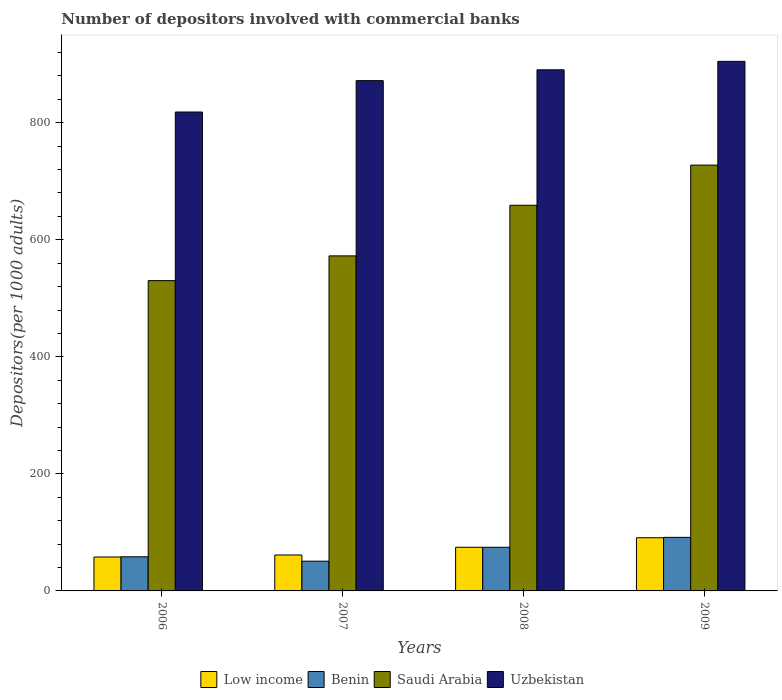How many different coloured bars are there?
Provide a succinct answer. 4. How many bars are there on the 3rd tick from the left?
Keep it short and to the point. 4. How many bars are there on the 2nd tick from the right?
Your answer should be compact. 4. What is the number of depositors involved with commercial banks in Benin in 2006?
Give a very brief answer. 58.31. Across all years, what is the maximum number of depositors involved with commercial banks in Saudi Arabia?
Provide a short and direct response. 727.65. Across all years, what is the minimum number of depositors involved with commercial banks in Low income?
Keep it short and to the point. 57.99. In which year was the number of depositors involved with commercial banks in Uzbekistan maximum?
Offer a very short reply. 2009. In which year was the number of depositors involved with commercial banks in Saudi Arabia minimum?
Your answer should be very brief. 2006. What is the total number of depositors involved with commercial banks in Low income in the graph?
Give a very brief answer. 284.91. What is the difference between the number of depositors involved with commercial banks in Uzbekistan in 2006 and that in 2007?
Ensure brevity in your answer.  -53.61. What is the difference between the number of depositors involved with commercial banks in Saudi Arabia in 2008 and the number of depositors involved with commercial banks in Uzbekistan in 2006?
Provide a succinct answer. -159.38. What is the average number of depositors involved with commercial banks in Saudi Arabia per year?
Your answer should be compact. 622.35. In the year 2008, what is the difference between the number of depositors involved with commercial banks in Saudi Arabia and number of depositors involved with commercial banks in Benin?
Provide a short and direct response. 584.4. What is the ratio of the number of depositors involved with commercial banks in Benin in 2007 to that in 2009?
Offer a very short reply. 0.56. What is the difference between the highest and the second highest number of depositors involved with commercial banks in Benin?
Offer a very short reply. 16.94. What is the difference between the highest and the lowest number of depositors involved with commercial banks in Saudi Arabia?
Give a very brief answer. 197.41. In how many years, is the number of depositors involved with commercial banks in Uzbekistan greater than the average number of depositors involved with commercial banks in Uzbekistan taken over all years?
Give a very brief answer. 3. Is it the case that in every year, the sum of the number of depositors involved with commercial banks in Uzbekistan and number of depositors involved with commercial banks in Saudi Arabia is greater than the sum of number of depositors involved with commercial banks in Low income and number of depositors involved with commercial banks in Benin?
Make the answer very short. Yes. What does the 4th bar from the left in 2006 represents?
Your answer should be compact. Uzbekistan. What does the 2nd bar from the right in 2006 represents?
Provide a succinct answer. Saudi Arabia. How many bars are there?
Offer a terse response. 16. Are all the bars in the graph horizontal?
Keep it short and to the point. No. How many years are there in the graph?
Your answer should be compact. 4. What is the difference between two consecutive major ticks on the Y-axis?
Keep it short and to the point. 200. Are the values on the major ticks of Y-axis written in scientific E-notation?
Keep it short and to the point. No. Does the graph contain grids?
Make the answer very short. No. How are the legend labels stacked?
Offer a terse response. Horizontal. What is the title of the graph?
Your answer should be very brief. Number of depositors involved with commercial banks. Does "Zimbabwe" appear as one of the legend labels in the graph?
Give a very brief answer. No. What is the label or title of the Y-axis?
Offer a very short reply. Depositors(per 1000 adults). What is the Depositors(per 1000 adults) in Low income in 2006?
Keep it short and to the point. 57.99. What is the Depositors(per 1000 adults) in Benin in 2006?
Provide a short and direct response. 58.31. What is the Depositors(per 1000 adults) of Saudi Arabia in 2006?
Your answer should be very brief. 530.23. What is the Depositors(per 1000 adults) of Uzbekistan in 2006?
Keep it short and to the point. 818.38. What is the Depositors(per 1000 adults) of Low income in 2007?
Your response must be concise. 61.41. What is the Depositors(per 1000 adults) in Benin in 2007?
Your answer should be very brief. 50.82. What is the Depositors(per 1000 adults) of Saudi Arabia in 2007?
Provide a succinct answer. 572.53. What is the Depositors(per 1000 adults) in Uzbekistan in 2007?
Provide a succinct answer. 871.99. What is the Depositors(per 1000 adults) of Low income in 2008?
Offer a terse response. 74.6. What is the Depositors(per 1000 adults) in Benin in 2008?
Give a very brief answer. 74.6. What is the Depositors(per 1000 adults) in Saudi Arabia in 2008?
Offer a terse response. 659. What is the Depositors(per 1000 adults) of Uzbekistan in 2008?
Ensure brevity in your answer.  890.51. What is the Depositors(per 1000 adults) of Low income in 2009?
Give a very brief answer. 90.91. What is the Depositors(per 1000 adults) of Benin in 2009?
Your response must be concise. 91.54. What is the Depositors(per 1000 adults) of Saudi Arabia in 2009?
Keep it short and to the point. 727.65. What is the Depositors(per 1000 adults) of Uzbekistan in 2009?
Your response must be concise. 904.94. Across all years, what is the maximum Depositors(per 1000 adults) of Low income?
Your answer should be very brief. 90.91. Across all years, what is the maximum Depositors(per 1000 adults) in Benin?
Your response must be concise. 91.54. Across all years, what is the maximum Depositors(per 1000 adults) in Saudi Arabia?
Provide a succinct answer. 727.65. Across all years, what is the maximum Depositors(per 1000 adults) in Uzbekistan?
Offer a very short reply. 904.94. Across all years, what is the minimum Depositors(per 1000 adults) of Low income?
Give a very brief answer. 57.99. Across all years, what is the minimum Depositors(per 1000 adults) of Benin?
Your answer should be very brief. 50.82. Across all years, what is the minimum Depositors(per 1000 adults) in Saudi Arabia?
Your response must be concise. 530.23. Across all years, what is the minimum Depositors(per 1000 adults) in Uzbekistan?
Keep it short and to the point. 818.38. What is the total Depositors(per 1000 adults) of Low income in the graph?
Provide a short and direct response. 284.91. What is the total Depositors(per 1000 adults) of Benin in the graph?
Provide a short and direct response. 275.28. What is the total Depositors(per 1000 adults) of Saudi Arabia in the graph?
Give a very brief answer. 2489.41. What is the total Depositors(per 1000 adults) of Uzbekistan in the graph?
Provide a succinct answer. 3485.81. What is the difference between the Depositors(per 1000 adults) of Low income in 2006 and that in 2007?
Your response must be concise. -3.42. What is the difference between the Depositors(per 1000 adults) in Benin in 2006 and that in 2007?
Keep it short and to the point. 7.5. What is the difference between the Depositors(per 1000 adults) in Saudi Arabia in 2006 and that in 2007?
Ensure brevity in your answer.  -42.3. What is the difference between the Depositors(per 1000 adults) of Uzbekistan in 2006 and that in 2007?
Provide a short and direct response. -53.61. What is the difference between the Depositors(per 1000 adults) in Low income in 2006 and that in 2008?
Offer a terse response. -16.61. What is the difference between the Depositors(per 1000 adults) in Benin in 2006 and that in 2008?
Offer a very short reply. -16.29. What is the difference between the Depositors(per 1000 adults) in Saudi Arabia in 2006 and that in 2008?
Give a very brief answer. -128.77. What is the difference between the Depositors(per 1000 adults) in Uzbekistan in 2006 and that in 2008?
Your response must be concise. -72.13. What is the difference between the Depositors(per 1000 adults) of Low income in 2006 and that in 2009?
Keep it short and to the point. -32.92. What is the difference between the Depositors(per 1000 adults) of Benin in 2006 and that in 2009?
Offer a very short reply. -33.23. What is the difference between the Depositors(per 1000 adults) of Saudi Arabia in 2006 and that in 2009?
Make the answer very short. -197.41. What is the difference between the Depositors(per 1000 adults) in Uzbekistan in 2006 and that in 2009?
Your response must be concise. -86.56. What is the difference between the Depositors(per 1000 adults) of Low income in 2007 and that in 2008?
Make the answer very short. -13.19. What is the difference between the Depositors(per 1000 adults) in Benin in 2007 and that in 2008?
Provide a succinct answer. -23.78. What is the difference between the Depositors(per 1000 adults) of Saudi Arabia in 2007 and that in 2008?
Make the answer very short. -86.47. What is the difference between the Depositors(per 1000 adults) of Uzbekistan in 2007 and that in 2008?
Give a very brief answer. -18.52. What is the difference between the Depositors(per 1000 adults) of Low income in 2007 and that in 2009?
Your response must be concise. -29.5. What is the difference between the Depositors(per 1000 adults) of Benin in 2007 and that in 2009?
Give a very brief answer. -40.72. What is the difference between the Depositors(per 1000 adults) in Saudi Arabia in 2007 and that in 2009?
Make the answer very short. -155.11. What is the difference between the Depositors(per 1000 adults) of Uzbekistan in 2007 and that in 2009?
Offer a very short reply. -32.96. What is the difference between the Depositors(per 1000 adults) in Low income in 2008 and that in 2009?
Your response must be concise. -16.31. What is the difference between the Depositors(per 1000 adults) in Benin in 2008 and that in 2009?
Make the answer very short. -16.94. What is the difference between the Depositors(per 1000 adults) of Saudi Arabia in 2008 and that in 2009?
Keep it short and to the point. -68.64. What is the difference between the Depositors(per 1000 adults) in Uzbekistan in 2008 and that in 2009?
Provide a succinct answer. -14.44. What is the difference between the Depositors(per 1000 adults) of Low income in 2006 and the Depositors(per 1000 adults) of Benin in 2007?
Make the answer very short. 7.17. What is the difference between the Depositors(per 1000 adults) of Low income in 2006 and the Depositors(per 1000 adults) of Saudi Arabia in 2007?
Keep it short and to the point. -514.54. What is the difference between the Depositors(per 1000 adults) of Low income in 2006 and the Depositors(per 1000 adults) of Uzbekistan in 2007?
Your answer should be compact. -814. What is the difference between the Depositors(per 1000 adults) in Benin in 2006 and the Depositors(per 1000 adults) in Saudi Arabia in 2007?
Your response must be concise. -514.22. What is the difference between the Depositors(per 1000 adults) of Benin in 2006 and the Depositors(per 1000 adults) of Uzbekistan in 2007?
Offer a terse response. -813.67. What is the difference between the Depositors(per 1000 adults) in Saudi Arabia in 2006 and the Depositors(per 1000 adults) in Uzbekistan in 2007?
Your answer should be very brief. -341.75. What is the difference between the Depositors(per 1000 adults) in Low income in 2006 and the Depositors(per 1000 adults) in Benin in 2008?
Offer a terse response. -16.61. What is the difference between the Depositors(per 1000 adults) in Low income in 2006 and the Depositors(per 1000 adults) in Saudi Arabia in 2008?
Your answer should be very brief. -601.01. What is the difference between the Depositors(per 1000 adults) in Low income in 2006 and the Depositors(per 1000 adults) in Uzbekistan in 2008?
Make the answer very short. -832.51. What is the difference between the Depositors(per 1000 adults) of Benin in 2006 and the Depositors(per 1000 adults) of Saudi Arabia in 2008?
Your response must be concise. -600.69. What is the difference between the Depositors(per 1000 adults) of Benin in 2006 and the Depositors(per 1000 adults) of Uzbekistan in 2008?
Offer a very short reply. -832.19. What is the difference between the Depositors(per 1000 adults) of Saudi Arabia in 2006 and the Depositors(per 1000 adults) of Uzbekistan in 2008?
Provide a short and direct response. -360.27. What is the difference between the Depositors(per 1000 adults) in Low income in 2006 and the Depositors(per 1000 adults) in Benin in 2009?
Offer a terse response. -33.55. What is the difference between the Depositors(per 1000 adults) in Low income in 2006 and the Depositors(per 1000 adults) in Saudi Arabia in 2009?
Give a very brief answer. -669.66. What is the difference between the Depositors(per 1000 adults) of Low income in 2006 and the Depositors(per 1000 adults) of Uzbekistan in 2009?
Offer a terse response. -846.95. What is the difference between the Depositors(per 1000 adults) in Benin in 2006 and the Depositors(per 1000 adults) in Saudi Arabia in 2009?
Your answer should be very brief. -669.33. What is the difference between the Depositors(per 1000 adults) in Benin in 2006 and the Depositors(per 1000 adults) in Uzbekistan in 2009?
Offer a terse response. -846.63. What is the difference between the Depositors(per 1000 adults) in Saudi Arabia in 2006 and the Depositors(per 1000 adults) in Uzbekistan in 2009?
Offer a very short reply. -374.71. What is the difference between the Depositors(per 1000 adults) in Low income in 2007 and the Depositors(per 1000 adults) in Benin in 2008?
Your answer should be very brief. -13.19. What is the difference between the Depositors(per 1000 adults) in Low income in 2007 and the Depositors(per 1000 adults) in Saudi Arabia in 2008?
Your response must be concise. -597.59. What is the difference between the Depositors(per 1000 adults) in Low income in 2007 and the Depositors(per 1000 adults) in Uzbekistan in 2008?
Your answer should be very brief. -829.1. What is the difference between the Depositors(per 1000 adults) of Benin in 2007 and the Depositors(per 1000 adults) of Saudi Arabia in 2008?
Ensure brevity in your answer.  -608.18. What is the difference between the Depositors(per 1000 adults) of Benin in 2007 and the Depositors(per 1000 adults) of Uzbekistan in 2008?
Offer a terse response. -839.69. What is the difference between the Depositors(per 1000 adults) of Saudi Arabia in 2007 and the Depositors(per 1000 adults) of Uzbekistan in 2008?
Your answer should be very brief. -317.97. What is the difference between the Depositors(per 1000 adults) in Low income in 2007 and the Depositors(per 1000 adults) in Benin in 2009?
Offer a terse response. -30.13. What is the difference between the Depositors(per 1000 adults) of Low income in 2007 and the Depositors(per 1000 adults) of Saudi Arabia in 2009?
Ensure brevity in your answer.  -666.24. What is the difference between the Depositors(per 1000 adults) of Low income in 2007 and the Depositors(per 1000 adults) of Uzbekistan in 2009?
Ensure brevity in your answer.  -843.53. What is the difference between the Depositors(per 1000 adults) in Benin in 2007 and the Depositors(per 1000 adults) in Saudi Arabia in 2009?
Offer a terse response. -676.83. What is the difference between the Depositors(per 1000 adults) in Benin in 2007 and the Depositors(per 1000 adults) in Uzbekistan in 2009?
Offer a very short reply. -854.12. What is the difference between the Depositors(per 1000 adults) of Saudi Arabia in 2007 and the Depositors(per 1000 adults) of Uzbekistan in 2009?
Your response must be concise. -332.41. What is the difference between the Depositors(per 1000 adults) of Low income in 2008 and the Depositors(per 1000 adults) of Benin in 2009?
Your response must be concise. -16.94. What is the difference between the Depositors(per 1000 adults) of Low income in 2008 and the Depositors(per 1000 adults) of Saudi Arabia in 2009?
Your answer should be very brief. -653.05. What is the difference between the Depositors(per 1000 adults) of Low income in 2008 and the Depositors(per 1000 adults) of Uzbekistan in 2009?
Provide a succinct answer. -830.34. What is the difference between the Depositors(per 1000 adults) of Benin in 2008 and the Depositors(per 1000 adults) of Saudi Arabia in 2009?
Your answer should be very brief. -653.05. What is the difference between the Depositors(per 1000 adults) of Benin in 2008 and the Depositors(per 1000 adults) of Uzbekistan in 2009?
Your answer should be very brief. -830.34. What is the difference between the Depositors(per 1000 adults) in Saudi Arabia in 2008 and the Depositors(per 1000 adults) in Uzbekistan in 2009?
Offer a very short reply. -245.94. What is the average Depositors(per 1000 adults) of Low income per year?
Your answer should be compact. 71.23. What is the average Depositors(per 1000 adults) in Benin per year?
Your response must be concise. 68.82. What is the average Depositors(per 1000 adults) of Saudi Arabia per year?
Make the answer very short. 622.35. What is the average Depositors(per 1000 adults) of Uzbekistan per year?
Make the answer very short. 871.45. In the year 2006, what is the difference between the Depositors(per 1000 adults) in Low income and Depositors(per 1000 adults) in Benin?
Offer a very short reply. -0.32. In the year 2006, what is the difference between the Depositors(per 1000 adults) of Low income and Depositors(per 1000 adults) of Saudi Arabia?
Give a very brief answer. -472.24. In the year 2006, what is the difference between the Depositors(per 1000 adults) in Low income and Depositors(per 1000 adults) in Uzbekistan?
Offer a very short reply. -760.39. In the year 2006, what is the difference between the Depositors(per 1000 adults) in Benin and Depositors(per 1000 adults) in Saudi Arabia?
Ensure brevity in your answer.  -471.92. In the year 2006, what is the difference between the Depositors(per 1000 adults) of Benin and Depositors(per 1000 adults) of Uzbekistan?
Your response must be concise. -760.06. In the year 2006, what is the difference between the Depositors(per 1000 adults) of Saudi Arabia and Depositors(per 1000 adults) of Uzbekistan?
Your answer should be very brief. -288.15. In the year 2007, what is the difference between the Depositors(per 1000 adults) of Low income and Depositors(per 1000 adults) of Benin?
Your answer should be very brief. 10.59. In the year 2007, what is the difference between the Depositors(per 1000 adults) of Low income and Depositors(per 1000 adults) of Saudi Arabia?
Offer a very short reply. -511.12. In the year 2007, what is the difference between the Depositors(per 1000 adults) in Low income and Depositors(per 1000 adults) in Uzbekistan?
Provide a succinct answer. -810.58. In the year 2007, what is the difference between the Depositors(per 1000 adults) of Benin and Depositors(per 1000 adults) of Saudi Arabia?
Make the answer very short. -521.71. In the year 2007, what is the difference between the Depositors(per 1000 adults) of Benin and Depositors(per 1000 adults) of Uzbekistan?
Your answer should be compact. -821.17. In the year 2007, what is the difference between the Depositors(per 1000 adults) in Saudi Arabia and Depositors(per 1000 adults) in Uzbekistan?
Keep it short and to the point. -299.45. In the year 2008, what is the difference between the Depositors(per 1000 adults) in Low income and Depositors(per 1000 adults) in Benin?
Your answer should be compact. 0. In the year 2008, what is the difference between the Depositors(per 1000 adults) in Low income and Depositors(per 1000 adults) in Saudi Arabia?
Give a very brief answer. -584.4. In the year 2008, what is the difference between the Depositors(per 1000 adults) in Low income and Depositors(per 1000 adults) in Uzbekistan?
Offer a terse response. -815.9. In the year 2008, what is the difference between the Depositors(per 1000 adults) of Benin and Depositors(per 1000 adults) of Saudi Arabia?
Ensure brevity in your answer.  -584.4. In the year 2008, what is the difference between the Depositors(per 1000 adults) of Benin and Depositors(per 1000 adults) of Uzbekistan?
Your response must be concise. -815.9. In the year 2008, what is the difference between the Depositors(per 1000 adults) of Saudi Arabia and Depositors(per 1000 adults) of Uzbekistan?
Make the answer very short. -231.5. In the year 2009, what is the difference between the Depositors(per 1000 adults) of Low income and Depositors(per 1000 adults) of Benin?
Keep it short and to the point. -0.63. In the year 2009, what is the difference between the Depositors(per 1000 adults) in Low income and Depositors(per 1000 adults) in Saudi Arabia?
Your answer should be very brief. -636.74. In the year 2009, what is the difference between the Depositors(per 1000 adults) of Low income and Depositors(per 1000 adults) of Uzbekistan?
Your answer should be compact. -814.03. In the year 2009, what is the difference between the Depositors(per 1000 adults) in Benin and Depositors(per 1000 adults) in Saudi Arabia?
Your answer should be very brief. -636.1. In the year 2009, what is the difference between the Depositors(per 1000 adults) of Benin and Depositors(per 1000 adults) of Uzbekistan?
Make the answer very short. -813.4. In the year 2009, what is the difference between the Depositors(per 1000 adults) of Saudi Arabia and Depositors(per 1000 adults) of Uzbekistan?
Offer a very short reply. -177.3. What is the ratio of the Depositors(per 1000 adults) in Low income in 2006 to that in 2007?
Make the answer very short. 0.94. What is the ratio of the Depositors(per 1000 adults) in Benin in 2006 to that in 2007?
Ensure brevity in your answer.  1.15. What is the ratio of the Depositors(per 1000 adults) in Saudi Arabia in 2006 to that in 2007?
Your answer should be very brief. 0.93. What is the ratio of the Depositors(per 1000 adults) of Uzbekistan in 2006 to that in 2007?
Your answer should be very brief. 0.94. What is the ratio of the Depositors(per 1000 adults) of Low income in 2006 to that in 2008?
Offer a very short reply. 0.78. What is the ratio of the Depositors(per 1000 adults) of Benin in 2006 to that in 2008?
Keep it short and to the point. 0.78. What is the ratio of the Depositors(per 1000 adults) in Saudi Arabia in 2006 to that in 2008?
Your answer should be very brief. 0.8. What is the ratio of the Depositors(per 1000 adults) in Uzbekistan in 2006 to that in 2008?
Give a very brief answer. 0.92. What is the ratio of the Depositors(per 1000 adults) of Low income in 2006 to that in 2009?
Keep it short and to the point. 0.64. What is the ratio of the Depositors(per 1000 adults) of Benin in 2006 to that in 2009?
Your response must be concise. 0.64. What is the ratio of the Depositors(per 1000 adults) of Saudi Arabia in 2006 to that in 2009?
Your response must be concise. 0.73. What is the ratio of the Depositors(per 1000 adults) in Uzbekistan in 2006 to that in 2009?
Offer a terse response. 0.9. What is the ratio of the Depositors(per 1000 adults) in Low income in 2007 to that in 2008?
Your answer should be very brief. 0.82. What is the ratio of the Depositors(per 1000 adults) of Benin in 2007 to that in 2008?
Make the answer very short. 0.68. What is the ratio of the Depositors(per 1000 adults) in Saudi Arabia in 2007 to that in 2008?
Your response must be concise. 0.87. What is the ratio of the Depositors(per 1000 adults) of Uzbekistan in 2007 to that in 2008?
Offer a very short reply. 0.98. What is the ratio of the Depositors(per 1000 adults) of Low income in 2007 to that in 2009?
Give a very brief answer. 0.68. What is the ratio of the Depositors(per 1000 adults) of Benin in 2007 to that in 2009?
Your answer should be compact. 0.56. What is the ratio of the Depositors(per 1000 adults) in Saudi Arabia in 2007 to that in 2009?
Offer a terse response. 0.79. What is the ratio of the Depositors(per 1000 adults) of Uzbekistan in 2007 to that in 2009?
Your response must be concise. 0.96. What is the ratio of the Depositors(per 1000 adults) in Low income in 2008 to that in 2009?
Your answer should be very brief. 0.82. What is the ratio of the Depositors(per 1000 adults) of Benin in 2008 to that in 2009?
Keep it short and to the point. 0.81. What is the ratio of the Depositors(per 1000 adults) of Saudi Arabia in 2008 to that in 2009?
Ensure brevity in your answer.  0.91. What is the ratio of the Depositors(per 1000 adults) in Uzbekistan in 2008 to that in 2009?
Keep it short and to the point. 0.98. What is the difference between the highest and the second highest Depositors(per 1000 adults) in Low income?
Provide a succinct answer. 16.31. What is the difference between the highest and the second highest Depositors(per 1000 adults) of Benin?
Provide a short and direct response. 16.94. What is the difference between the highest and the second highest Depositors(per 1000 adults) in Saudi Arabia?
Make the answer very short. 68.64. What is the difference between the highest and the second highest Depositors(per 1000 adults) in Uzbekistan?
Keep it short and to the point. 14.44. What is the difference between the highest and the lowest Depositors(per 1000 adults) in Low income?
Your response must be concise. 32.92. What is the difference between the highest and the lowest Depositors(per 1000 adults) of Benin?
Give a very brief answer. 40.72. What is the difference between the highest and the lowest Depositors(per 1000 adults) of Saudi Arabia?
Your answer should be very brief. 197.41. What is the difference between the highest and the lowest Depositors(per 1000 adults) of Uzbekistan?
Give a very brief answer. 86.56. 